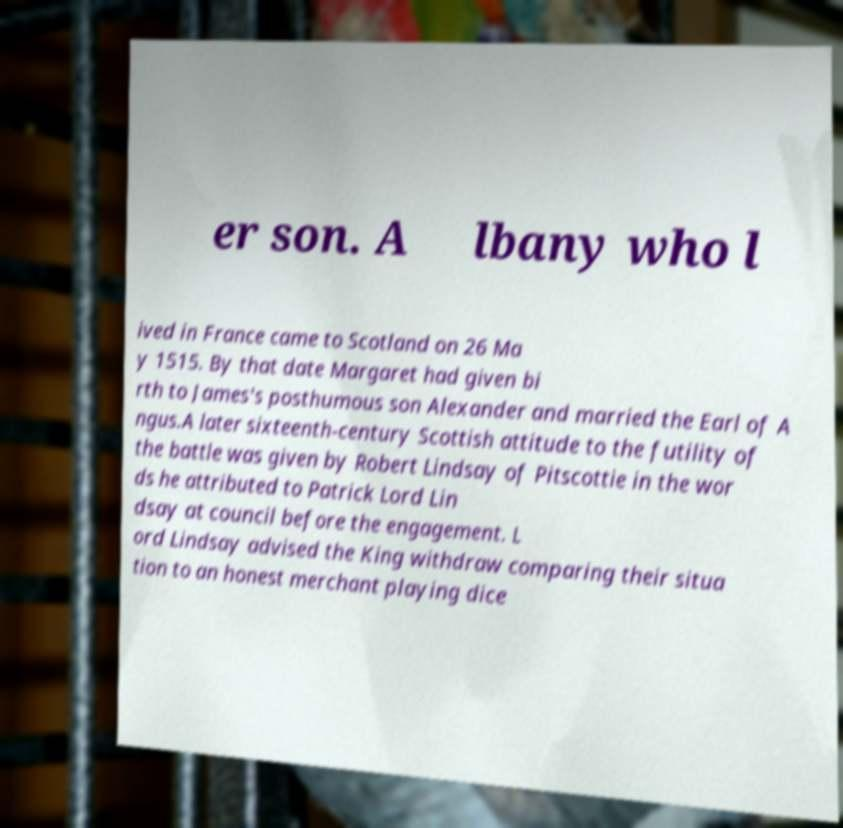Can you accurately transcribe the text from the provided image for me? er son. A lbany who l ived in France came to Scotland on 26 Ma y 1515. By that date Margaret had given bi rth to James's posthumous son Alexander and married the Earl of A ngus.A later sixteenth-century Scottish attitude to the futility of the battle was given by Robert Lindsay of Pitscottie in the wor ds he attributed to Patrick Lord Lin dsay at council before the engagement. L ord Lindsay advised the King withdraw comparing their situa tion to an honest merchant playing dice 